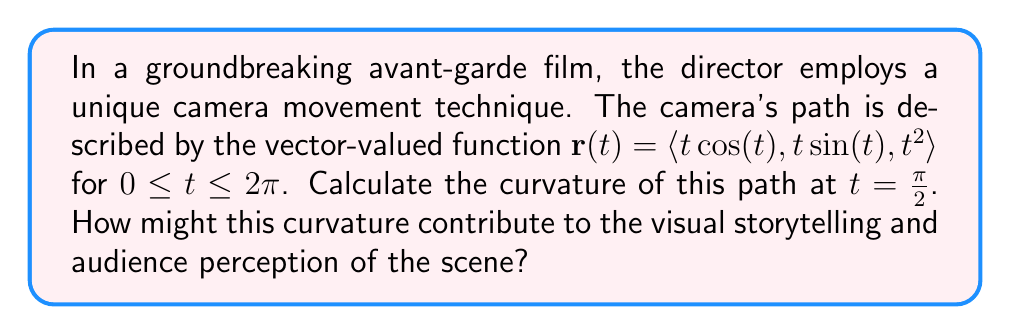Solve this math problem. To analyze the curvature of the camera movement path, we'll use the formula for the curvature of a vector-valued function:

$$\kappa = \frac{|\mathbf{r}'(t) \times \mathbf{r}''(t)|}{|\mathbf{r}'(t)|^3}$$

Step 1: Calculate $\mathbf{r}'(t)$
$$\mathbf{r}'(t) = \langle \cos(t) - t\sin(t), \sin(t) + t\cos(t), 2t \rangle$$

Step 2: Calculate $\mathbf{r}''(t)$
$$\mathbf{r}''(t) = \langle -2\sin(t) - t\cos(t), 2\cos(t) - t\sin(t), 2 \rangle$$

Step 3: Evaluate $\mathbf{r}'(t)$ and $\mathbf{r}''(t)$ at $t = \frac{\pi}{2}$
$$\mathbf{r}'(\frac{\pi}{2}) = \langle -\frac{\pi}{2}, 1, \pi \rangle$$
$$\mathbf{r}''(\frac{\pi}{2}) = \langle -2, -\frac{\pi}{2}, 2 \rangle$$

Step 4: Calculate the cross product $\mathbf{r}'(\frac{\pi}{2}) \times \mathbf{r}''(\frac{\pi}{2})$
$$\mathbf{r}'(\frac{\pi}{2}) \times \mathbf{r}''(\frac{\pi}{2}) = \langle -\frac{\pi^2}{2}-2, -\pi-\frac{\pi^2}{4}, -1-\frac{\pi^2}{4} \rangle$$

Step 5: Calculate the magnitudes
$$|\mathbf{r}'(\frac{\pi}{2}) \times \mathbf{r}''(\frac{\pi}{2})| = \sqrt{(\frac{\pi^2}{2}+2)^2 + (\pi+\frac{\pi^2}{4})^2 + (1+\frac{\pi^2}{4})^2}$$
$$|\mathbf{r}'(\frac{\pi}{2})|^3 = (\sqrt{(\frac{\pi}{2})^2 + 1^2 + \pi^2})^3 = (\sqrt{\frac{\pi^2}{4} + 1 + \pi^2})^3 = (\sqrt{\frac{5\pi^2}{4} + 1})^3$$

Step 6: Calculate the curvature
$$\kappa = \frac{\sqrt{(\frac{\pi^2}{2}+2)^2 + (\pi+\frac{\pi^2}{4})^2 + (1+\frac{\pi^2}{4})^2}}{(\sqrt{\frac{5\pi^2}{4} + 1})^3}$$

This curvature value represents the rate of change of the camera's direction at $t = \frac{\pi}{2}$. A higher curvature indicates a sharper turn, which could create a more dynamic and disorienting effect for the audience. This might be used to enhance tension, represent a character's emotional state, or emphasize a plot twist in the film's narrative.
Answer: The curvature of the camera movement path at $t = \frac{\pi}{2}$ is:

$$\kappa = \frac{\sqrt{(\frac{\pi^2}{2}+2)^2 + (\pi+\frac{\pi^2}{4})^2 + (1+\frac{\pi^2}{4})^2}}{(\sqrt{\frac{5\pi^2}{4} + 1})^3}$$

This precise mathematical description of the camera's movement can be used to analyze how the director manipulates space and perspective to create specific emotional or narrative effects in the film. 